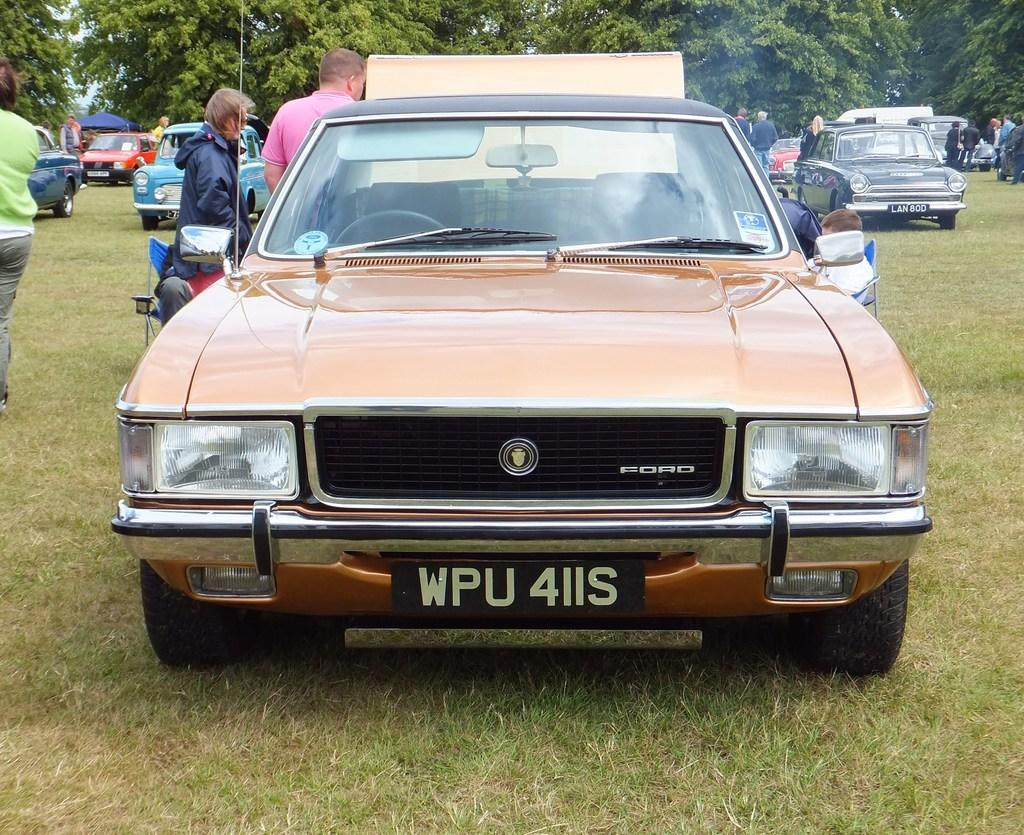What type of vehicles can be seen in the image? There are cars in the image. What are the people in the image doing? There are persons standing and sitting in the image. What is the ground surface like in the image? There is grass on the ground in the image. What can be seen in the background of the image? There are trees in the background of the image. What type of pet can be seen in the image? There is no pet visible in the image. Who is taking the picture of the scene in the image? There is no camera or person taking a picture present in the image. 